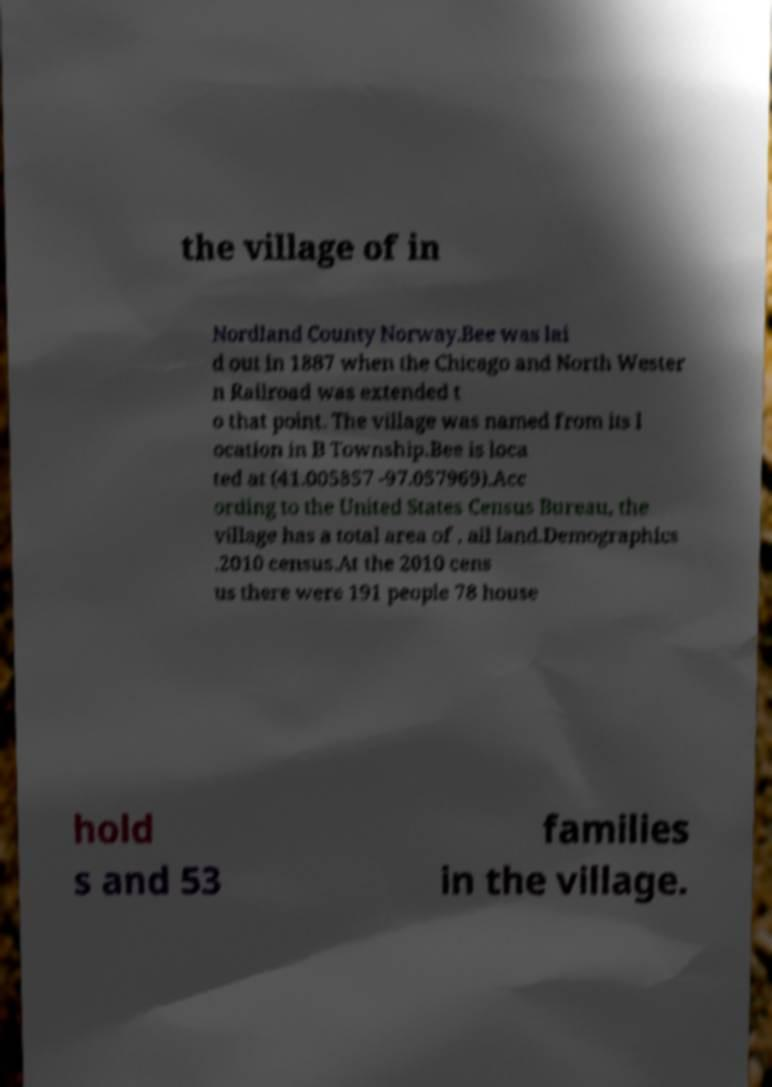There's text embedded in this image that I need extracted. Can you transcribe it verbatim? the village of in Nordland County Norway.Bee was lai d out in 1887 when the Chicago and North Wester n Railroad was extended t o that point. The village was named from its l ocation in B Township.Bee is loca ted at (41.005857 -97.057969).Acc ording to the United States Census Bureau, the village has a total area of , all land.Demographics .2010 census.At the 2010 cens us there were 191 people 78 house hold s and 53 families in the village. 